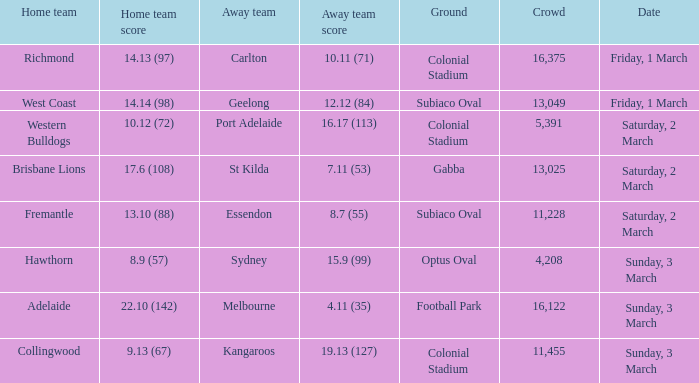6 (108)? St Kilda. 